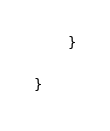Convert code to text. <code><loc_0><loc_0><loc_500><loc_500><_Kotlin_>    }

}
</code> 